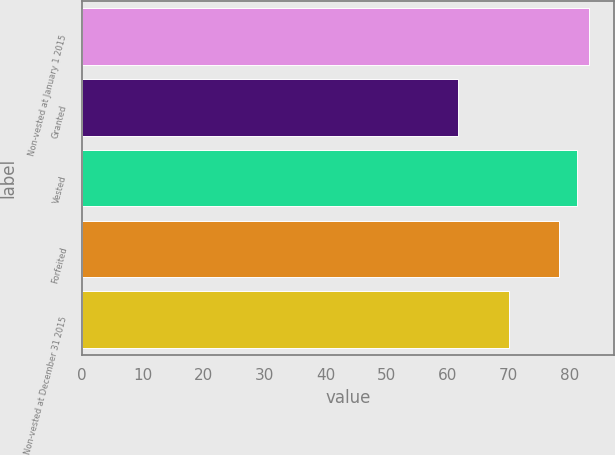Convert chart. <chart><loc_0><loc_0><loc_500><loc_500><bar_chart><fcel>Non-vested at January 1 2015<fcel>Granted<fcel>Vested<fcel>Forfeited<fcel>Non-vested at December 31 2015<nl><fcel>83.17<fcel>61.65<fcel>81.14<fcel>78.26<fcel>70.12<nl></chart> 